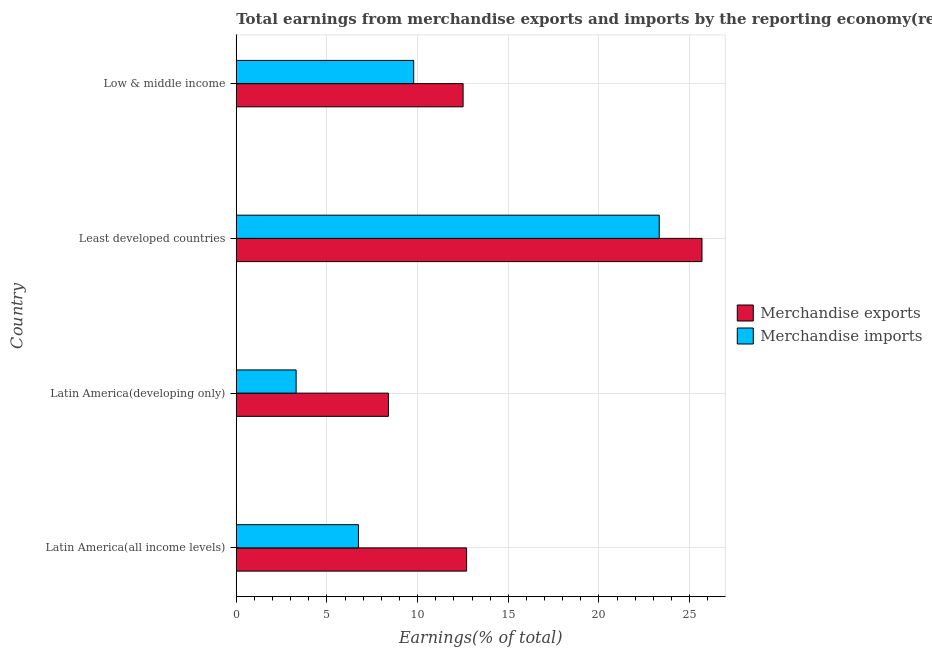Are the number of bars per tick equal to the number of legend labels?
Your answer should be very brief. Yes. Are the number of bars on each tick of the Y-axis equal?
Offer a terse response. Yes. How many bars are there on the 1st tick from the top?
Offer a terse response. 2. How many bars are there on the 1st tick from the bottom?
Give a very brief answer. 2. What is the label of the 4th group of bars from the top?
Ensure brevity in your answer.  Latin America(all income levels). What is the earnings from merchandise imports in Least developed countries?
Offer a terse response. 23.32. Across all countries, what is the maximum earnings from merchandise imports?
Offer a terse response. 23.32. Across all countries, what is the minimum earnings from merchandise imports?
Provide a succinct answer. 3.3. In which country was the earnings from merchandise imports maximum?
Provide a short and direct response. Least developed countries. In which country was the earnings from merchandise imports minimum?
Provide a short and direct response. Latin America(developing only). What is the total earnings from merchandise exports in the graph?
Offer a terse response. 59.29. What is the difference between the earnings from merchandise exports in Latin America(developing only) and that in Low & middle income?
Your answer should be very brief. -4.12. What is the difference between the earnings from merchandise exports in Least developed countries and the earnings from merchandise imports in Latin America(developing only)?
Provide a succinct answer. 22.38. What is the average earnings from merchandise exports per country?
Provide a short and direct response. 14.82. What is the difference between the earnings from merchandise exports and earnings from merchandise imports in Low & middle income?
Your response must be concise. 2.72. In how many countries, is the earnings from merchandise imports greater than 24 %?
Your answer should be compact. 0. What is the ratio of the earnings from merchandise exports in Least developed countries to that in Low & middle income?
Your response must be concise. 2.05. What is the difference between the highest and the second highest earnings from merchandise exports?
Provide a short and direct response. 12.98. What is the difference between the highest and the lowest earnings from merchandise imports?
Provide a short and direct response. 20.02. In how many countries, is the earnings from merchandise exports greater than the average earnings from merchandise exports taken over all countries?
Offer a terse response. 1. Is the sum of the earnings from merchandise imports in Latin America(all income levels) and Low & middle income greater than the maximum earnings from merchandise exports across all countries?
Make the answer very short. No. What does the 2nd bar from the top in Least developed countries represents?
Make the answer very short. Merchandise exports. Are all the bars in the graph horizontal?
Keep it short and to the point. Yes. Does the graph contain any zero values?
Give a very brief answer. No. Does the graph contain grids?
Provide a short and direct response. Yes. How many legend labels are there?
Ensure brevity in your answer.  2. What is the title of the graph?
Keep it short and to the point. Total earnings from merchandise exports and imports by the reporting economy(residual) in 1975. Does "Boys" appear as one of the legend labels in the graph?
Your answer should be very brief. No. What is the label or title of the X-axis?
Make the answer very short. Earnings(% of total). What is the label or title of the Y-axis?
Your answer should be compact. Country. What is the Earnings(% of total) of Merchandise exports in Latin America(all income levels)?
Your response must be concise. 12.7. What is the Earnings(% of total) in Merchandise imports in Latin America(all income levels)?
Your answer should be very brief. 6.74. What is the Earnings(% of total) in Merchandise exports in Latin America(developing only)?
Offer a very short reply. 8.39. What is the Earnings(% of total) in Merchandise imports in Latin America(developing only)?
Provide a short and direct response. 3.3. What is the Earnings(% of total) of Merchandise exports in Least developed countries?
Give a very brief answer. 25.68. What is the Earnings(% of total) of Merchandise imports in Least developed countries?
Give a very brief answer. 23.32. What is the Earnings(% of total) in Merchandise exports in Low & middle income?
Offer a terse response. 12.51. What is the Earnings(% of total) in Merchandise imports in Low & middle income?
Offer a very short reply. 9.79. Across all countries, what is the maximum Earnings(% of total) in Merchandise exports?
Your response must be concise. 25.68. Across all countries, what is the maximum Earnings(% of total) in Merchandise imports?
Your answer should be compact. 23.32. Across all countries, what is the minimum Earnings(% of total) in Merchandise exports?
Offer a terse response. 8.39. Across all countries, what is the minimum Earnings(% of total) in Merchandise imports?
Your answer should be very brief. 3.3. What is the total Earnings(% of total) of Merchandise exports in the graph?
Provide a succinct answer. 59.29. What is the total Earnings(% of total) in Merchandise imports in the graph?
Your answer should be compact. 43.15. What is the difference between the Earnings(% of total) of Merchandise exports in Latin America(all income levels) and that in Latin America(developing only)?
Give a very brief answer. 4.31. What is the difference between the Earnings(% of total) in Merchandise imports in Latin America(all income levels) and that in Latin America(developing only)?
Your response must be concise. 3.44. What is the difference between the Earnings(% of total) in Merchandise exports in Latin America(all income levels) and that in Least developed countries?
Offer a terse response. -12.98. What is the difference between the Earnings(% of total) of Merchandise imports in Latin America(all income levels) and that in Least developed countries?
Provide a short and direct response. -16.59. What is the difference between the Earnings(% of total) in Merchandise exports in Latin America(all income levels) and that in Low & middle income?
Offer a very short reply. 0.19. What is the difference between the Earnings(% of total) in Merchandise imports in Latin America(all income levels) and that in Low & middle income?
Ensure brevity in your answer.  -3.05. What is the difference between the Earnings(% of total) in Merchandise exports in Latin America(developing only) and that in Least developed countries?
Ensure brevity in your answer.  -17.29. What is the difference between the Earnings(% of total) in Merchandise imports in Latin America(developing only) and that in Least developed countries?
Your response must be concise. -20.02. What is the difference between the Earnings(% of total) in Merchandise exports in Latin America(developing only) and that in Low & middle income?
Your response must be concise. -4.12. What is the difference between the Earnings(% of total) in Merchandise imports in Latin America(developing only) and that in Low & middle income?
Your answer should be very brief. -6.48. What is the difference between the Earnings(% of total) of Merchandise exports in Least developed countries and that in Low & middle income?
Your response must be concise. 13.17. What is the difference between the Earnings(% of total) in Merchandise imports in Least developed countries and that in Low & middle income?
Make the answer very short. 13.54. What is the difference between the Earnings(% of total) in Merchandise exports in Latin America(all income levels) and the Earnings(% of total) in Merchandise imports in Latin America(developing only)?
Ensure brevity in your answer.  9.4. What is the difference between the Earnings(% of total) in Merchandise exports in Latin America(all income levels) and the Earnings(% of total) in Merchandise imports in Least developed countries?
Your response must be concise. -10.62. What is the difference between the Earnings(% of total) of Merchandise exports in Latin America(all income levels) and the Earnings(% of total) of Merchandise imports in Low & middle income?
Offer a very short reply. 2.92. What is the difference between the Earnings(% of total) of Merchandise exports in Latin America(developing only) and the Earnings(% of total) of Merchandise imports in Least developed countries?
Your answer should be compact. -14.93. What is the difference between the Earnings(% of total) in Merchandise exports in Latin America(developing only) and the Earnings(% of total) in Merchandise imports in Low & middle income?
Offer a terse response. -1.39. What is the difference between the Earnings(% of total) in Merchandise exports in Least developed countries and the Earnings(% of total) in Merchandise imports in Low & middle income?
Provide a short and direct response. 15.9. What is the average Earnings(% of total) of Merchandise exports per country?
Your answer should be very brief. 14.82. What is the average Earnings(% of total) in Merchandise imports per country?
Offer a very short reply. 10.79. What is the difference between the Earnings(% of total) in Merchandise exports and Earnings(% of total) in Merchandise imports in Latin America(all income levels)?
Provide a short and direct response. 5.96. What is the difference between the Earnings(% of total) of Merchandise exports and Earnings(% of total) of Merchandise imports in Latin America(developing only)?
Your answer should be very brief. 5.09. What is the difference between the Earnings(% of total) of Merchandise exports and Earnings(% of total) of Merchandise imports in Least developed countries?
Give a very brief answer. 2.36. What is the difference between the Earnings(% of total) in Merchandise exports and Earnings(% of total) in Merchandise imports in Low & middle income?
Provide a short and direct response. 2.72. What is the ratio of the Earnings(% of total) of Merchandise exports in Latin America(all income levels) to that in Latin America(developing only)?
Make the answer very short. 1.51. What is the ratio of the Earnings(% of total) of Merchandise imports in Latin America(all income levels) to that in Latin America(developing only)?
Ensure brevity in your answer.  2.04. What is the ratio of the Earnings(% of total) in Merchandise exports in Latin America(all income levels) to that in Least developed countries?
Give a very brief answer. 0.49. What is the ratio of the Earnings(% of total) of Merchandise imports in Latin America(all income levels) to that in Least developed countries?
Ensure brevity in your answer.  0.29. What is the ratio of the Earnings(% of total) in Merchandise exports in Latin America(all income levels) to that in Low & middle income?
Provide a succinct answer. 1.02. What is the ratio of the Earnings(% of total) of Merchandise imports in Latin America(all income levels) to that in Low & middle income?
Your answer should be compact. 0.69. What is the ratio of the Earnings(% of total) in Merchandise exports in Latin America(developing only) to that in Least developed countries?
Your response must be concise. 0.33. What is the ratio of the Earnings(% of total) of Merchandise imports in Latin America(developing only) to that in Least developed countries?
Give a very brief answer. 0.14. What is the ratio of the Earnings(% of total) of Merchandise exports in Latin America(developing only) to that in Low & middle income?
Offer a very short reply. 0.67. What is the ratio of the Earnings(% of total) in Merchandise imports in Latin America(developing only) to that in Low & middle income?
Ensure brevity in your answer.  0.34. What is the ratio of the Earnings(% of total) of Merchandise exports in Least developed countries to that in Low & middle income?
Make the answer very short. 2.05. What is the ratio of the Earnings(% of total) in Merchandise imports in Least developed countries to that in Low & middle income?
Provide a short and direct response. 2.38. What is the difference between the highest and the second highest Earnings(% of total) in Merchandise exports?
Ensure brevity in your answer.  12.98. What is the difference between the highest and the second highest Earnings(% of total) of Merchandise imports?
Your answer should be very brief. 13.54. What is the difference between the highest and the lowest Earnings(% of total) in Merchandise exports?
Provide a short and direct response. 17.29. What is the difference between the highest and the lowest Earnings(% of total) of Merchandise imports?
Make the answer very short. 20.02. 